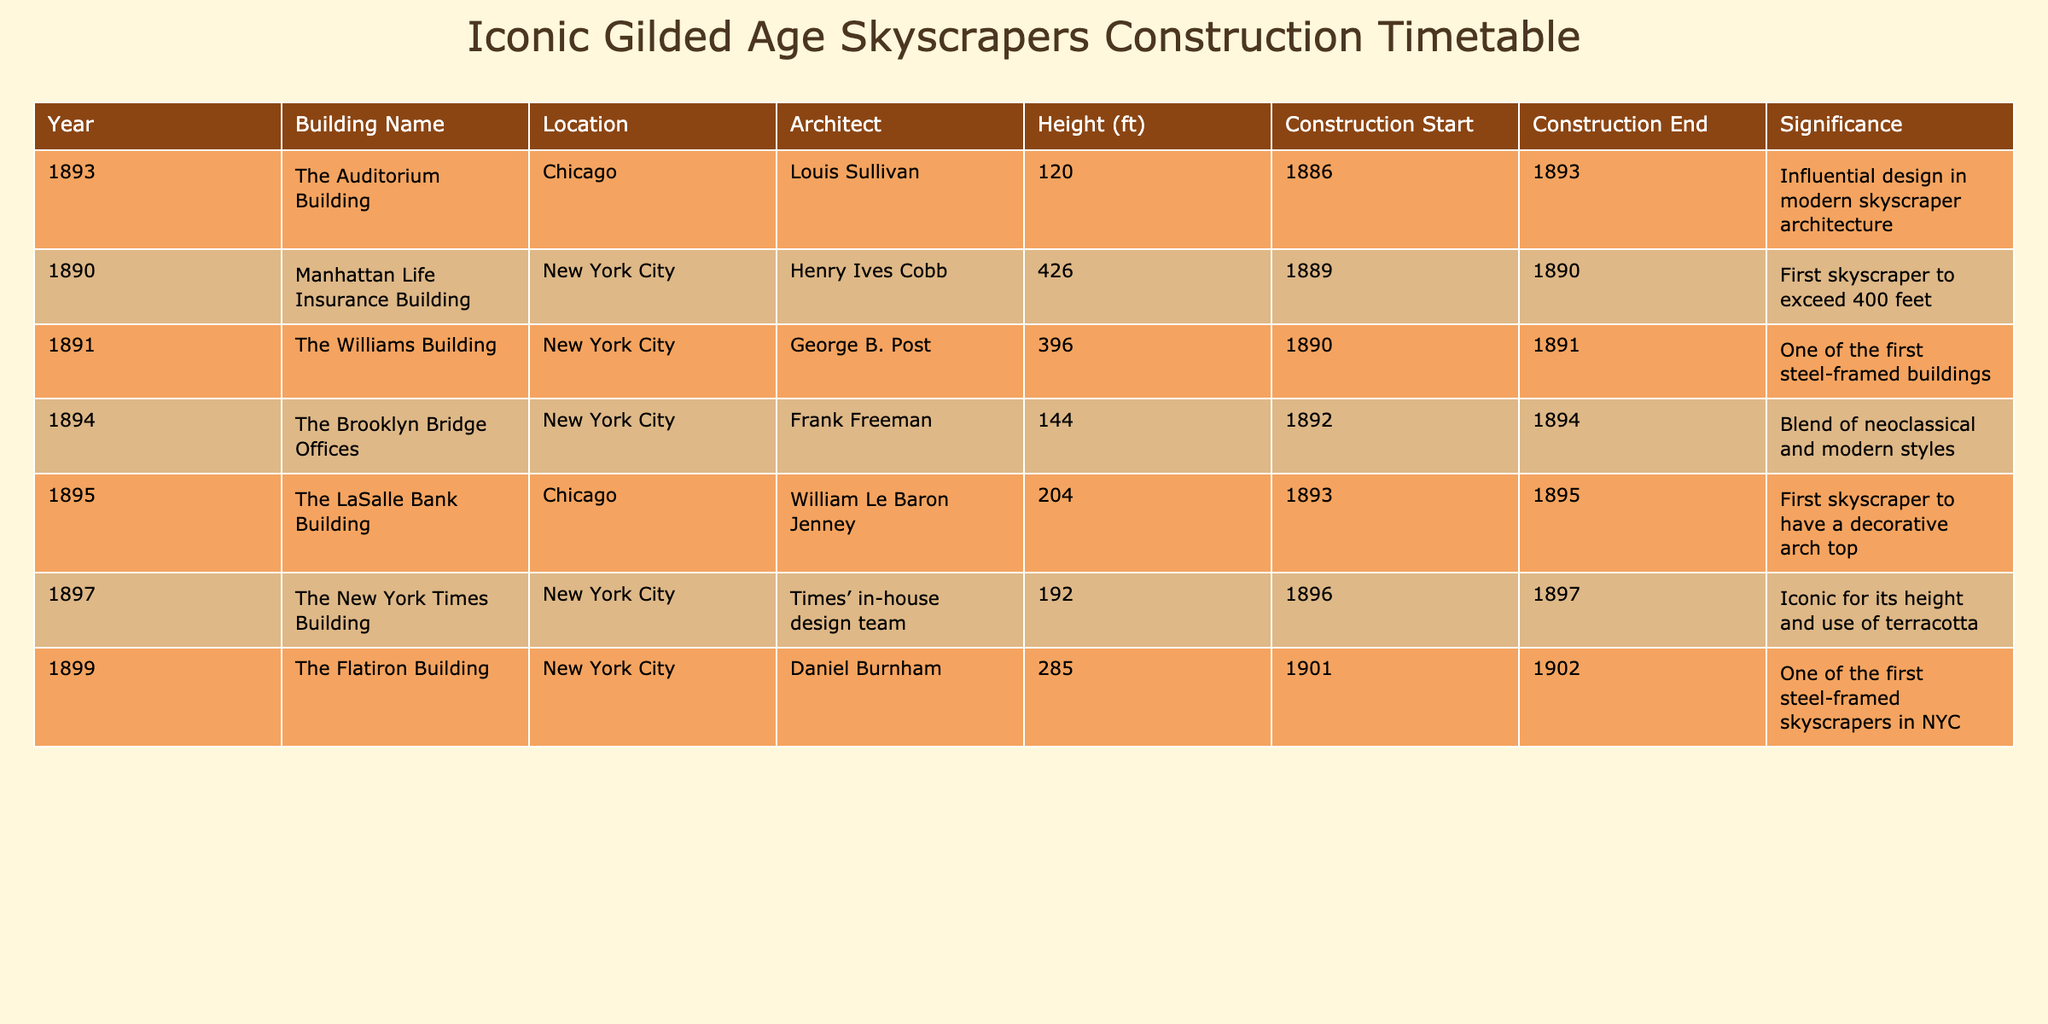What year was the Manhattan Life Insurance Building completed? The table shows that the construction of the Manhattan Life Insurance Building started in 1889 and ended in 1890, so it was completed in 1890.
Answer: 1890 Which building was constructed first, The Williams Building or The Brooklyn Bridge Offices? According to the construction start dates listed in the table, The Williams Building started in 1890 and The Brooklyn Bridge Offices started in 1892. Therefore, The Williams Building was constructed first.
Answer: The Williams Building What is the height difference between The Flatiron Building and The LaSalle Bank Building? The table states that The Flatiron Building has a height of 285 feet and The LaSalle Bank Building has a height of 204 feet. The height difference can be calculated as 285 - 204 = 81 feet.
Answer: 81 feet Did all buildings listed in the table exceed a height of 200 feet? By checking the height column, The Auditorium Building at only 120 feet does not exceed 200 feet, while all others do. Therefore, the answer is no.
Answer: No Which architect designed the tallest building in this table? Among the listed buildings, the tallest is the Manhattan Life Insurance Building at 426 feet, which was designed by Henry Ives Cobb.
Answer: Henry Ives Cobb What was the average height of the buildings constructed between 1891 and 1894? The buildings in this range are The Williams Building (396 ft), The Auditorium Building (120 ft), The Brooklyn Bridge Offices (144 ft), and The LaSalle Bank Building (204 ft). The average height is calculated by summing these heights (396 + 120 + 144 + 204 = 864) and dividing by four (864 / 4 = 216).
Answer: 216 feet How many buildings were constructed after 1895? The table lists buildings with a construction end date of 1895 or later, specifically The New York Times Building (1897), The Flatiron Building (1902), and the total is three buildings.
Answer: 3 Was there ever a building in this list designed by Louis Sullivan? The table indicates that the Auditorium Building was designed by Louis Sullivan, confirming that there is indeed a building from this architect listed.
Answer: Yes Which city had more skyscrapers in this table, New York City or Chicago? Upon reviewing the table, New York City has five entries (Manhattan Life Insurance Building, The Williams Building, The Brooklyn Bridge Offices, The New York Times Building, The Flatiron Building) while Chicago has three (The Auditorium Building and The LaSalle Bank Building). Hence, New York City had more skyscrapers in this list.
Answer: New York City 